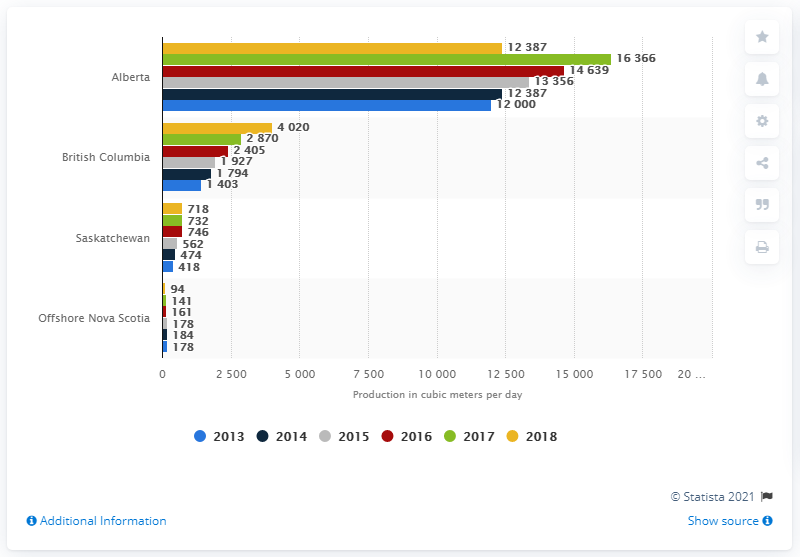Outline some significant characteristics in this image. Alberta is the largest producer of butane in Canada. 